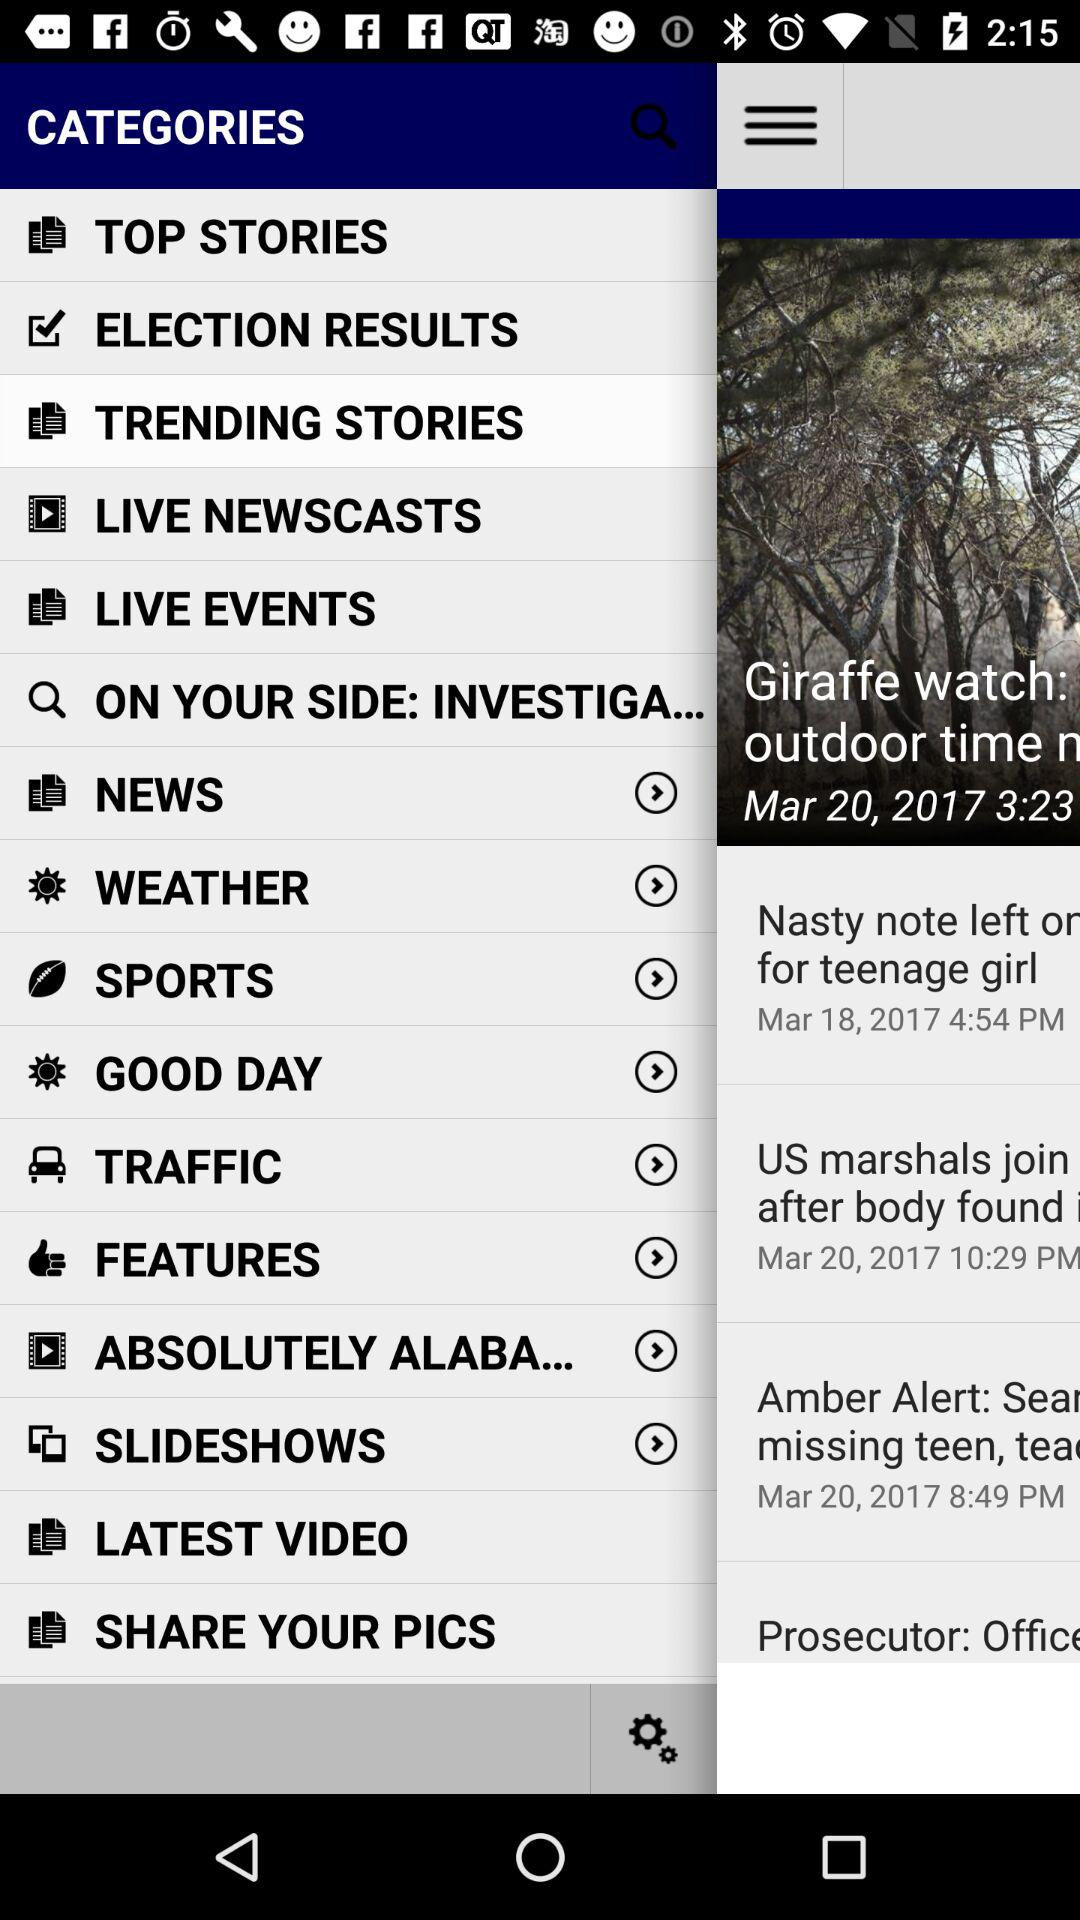How many items have a forward arrow?
Answer the question using a single word or phrase. 8 